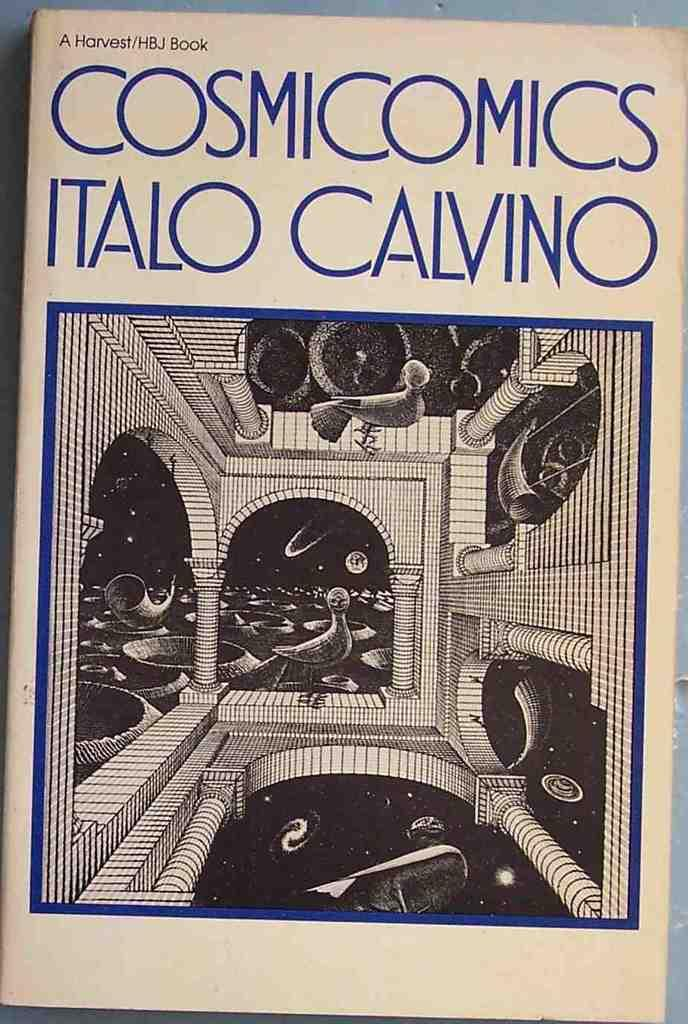<image>
Offer a succinct explanation of the picture presented. Comic book called Cosmic Comics Italo Calvino being displayed 